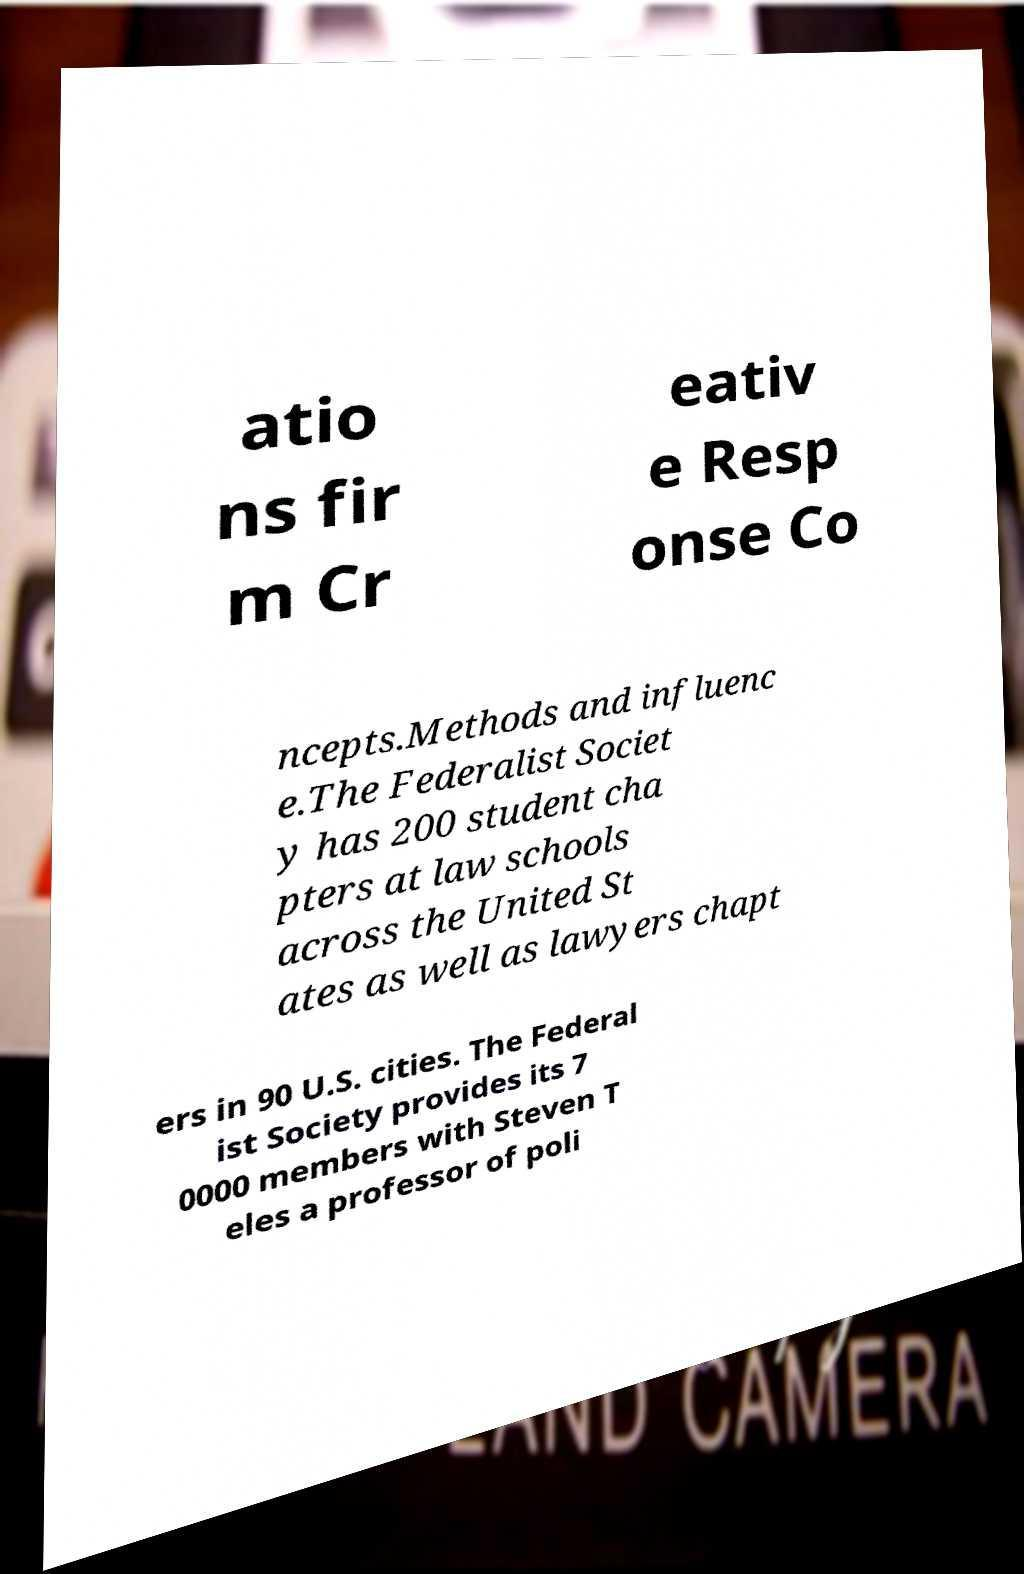For documentation purposes, I need the text within this image transcribed. Could you provide that? atio ns fir m Cr eativ e Resp onse Co ncepts.Methods and influenc e.The Federalist Societ y has 200 student cha pters at law schools across the United St ates as well as lawyers chapt ers in 90 U.S. cities. The Federal ist Society provides its 7 0000 members with Steven T eles a professor of poli 